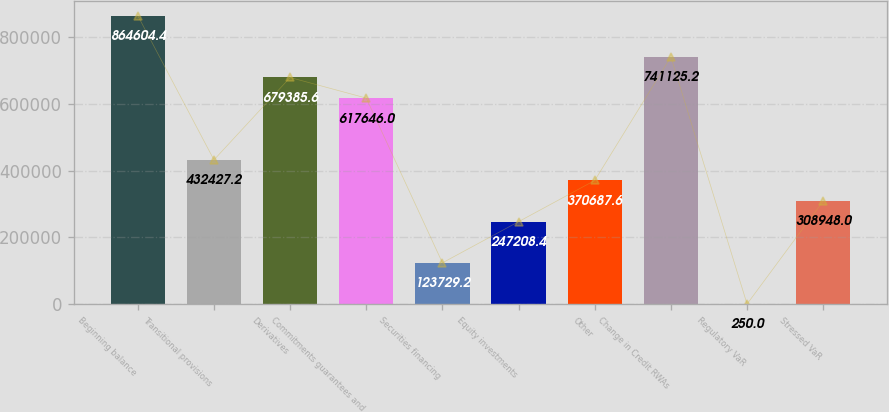Convert chart to OTSL. <chart><loc_0><loc_0><loc_500><loc_500><bar_chart><fcel>Beginning balance<fcel>Transitional provisions<fcel>Derivatives<fcel>Commitments guarantees and<fcel>Securities financing<fcel>Equity investments<fcel>Other<fcel>Change in Credit RWAs<fcel>Regulatory VaR<fcel>Stressed VaR<nl><fcel>864604<fcel>432427<fcel>679386<fcel>617646<fcel>123729<fcel>247208<fcel>370688<fcel>741125<fcel>250<fcel>308948<nl></chart> 